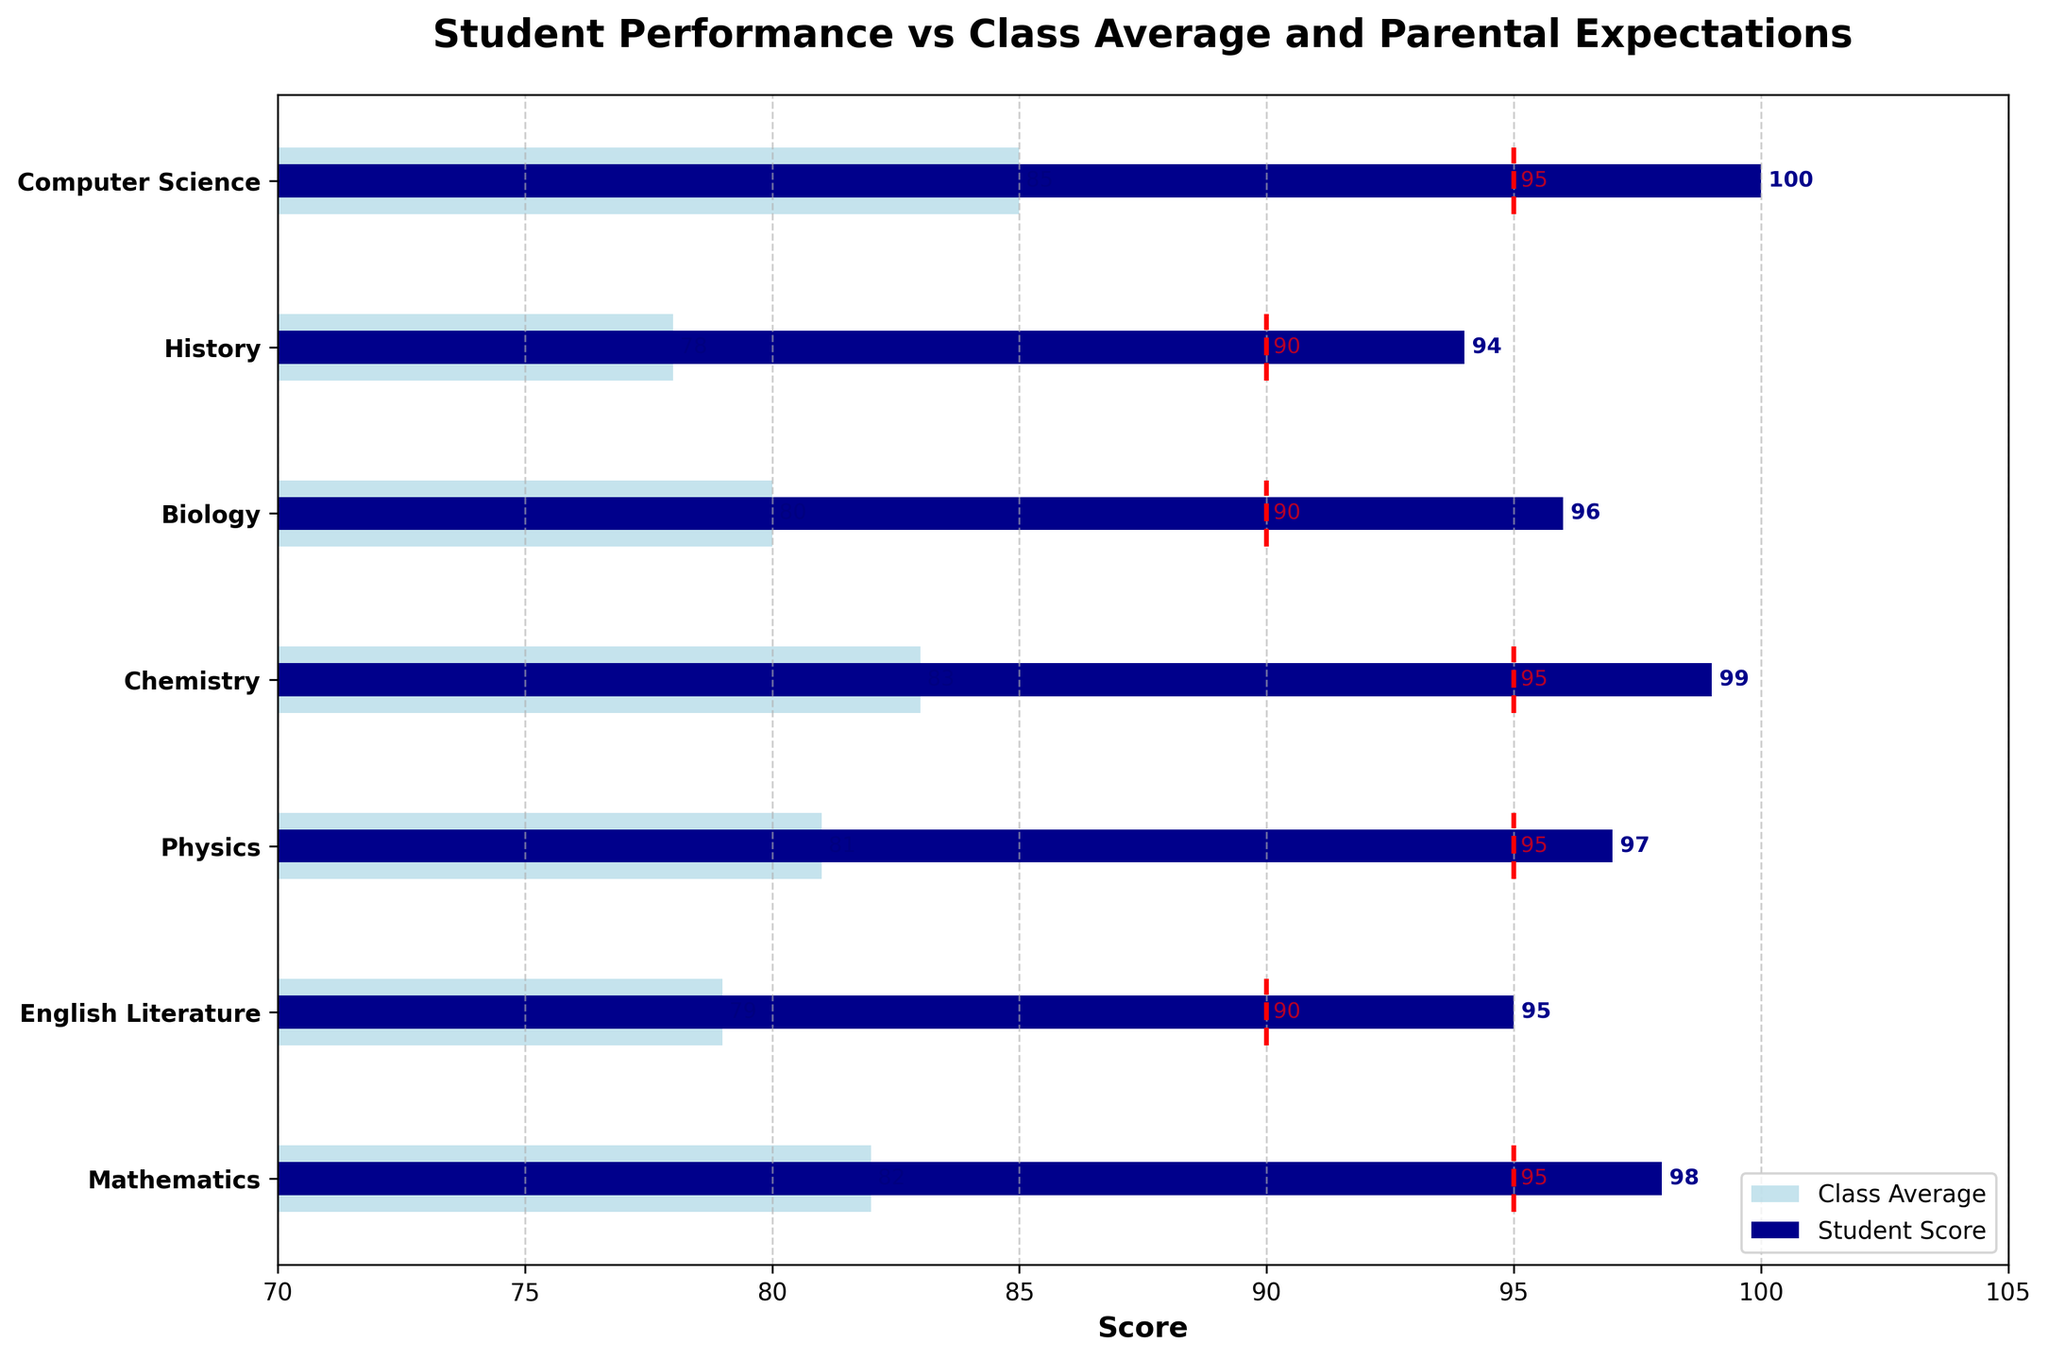What is the title of the figure? The title is usually displayed at the top of the figure, giving a description or overview of what the chart represents. In this case, it indicates the context of the data being shown.
Answer: Student Performance vs Class Average and Parental Expectations What color represents the student's scores? Observing the bars in the figure, we notice different colors. Dark blue is used for the student's scores.
Answer: Dark blue How many subjects are included in the figure? Count the number of labels along the vertical axis. The y-axis lists all the subjects considered in the analysis.
Answer: 7 Which subject does the student have the highest score in? To determine this, compare the lengths of the dark blue bars. The longest one corresponds to the highest score.
Answer: Computer Science In which subject is the class average closest to the student's score? Compare the dark blue bars (student scores) and the light blue bars (class averages). The closest pair will have the smallest visual gap between the two bars.
Answer: Mathematics How much higher is the student's score in Chemistry compared to Biology? Find the scores for Chemistry and Biology from the bars. Subtract the Biology score from the Chemistry score to find the difference.
Answer: 3 What is the range of the parental expectations shown in the chart? Look at the dotted red lines representing parental expectations across subjects and identify the minimum and maximum values. Subtract the minimum value from the maximum to find the range.
Answer: 90 to 95 How does the student's score in English Literature compare to the parental expectation for that subject? Find the student's score and the parental expectation for English Literature. Compare the two values to see if the student's score is higher, lower, or equal.
Answer: Higher In which subject is the difference between the class average and the student's score the greatest? Calculate the difference between the student score and class average for each subject, and then identify which subject has the largest difference.
Answer: Computer Science Does the student meet the parental expectations for any subjects? Compare the student's score against the parental expectations for all subjects. Determine if any student's score is equal to or exceeds the parental expectation.
Answer: Yes 